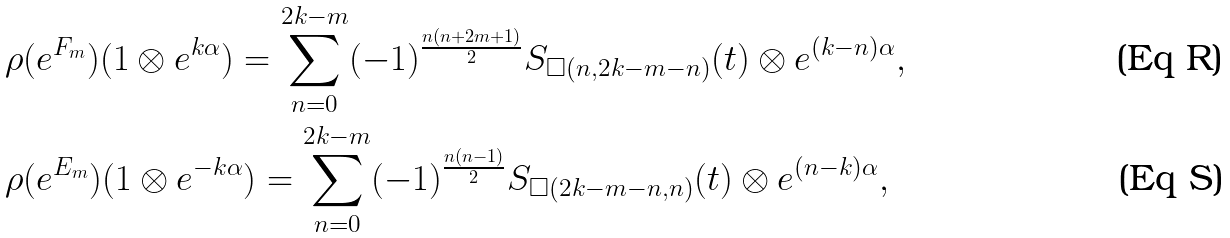<formula> <loc_0><loc_0><loc_500><loc_500>& \rho ( e ^ { F _ { m } } ) ( 1 \otimes e ^ { k \alpha } ) = \sum _ { n = 0 } ^ { 2 k - m } ( - 1 ) ^ { \frac { n ( n + 2 m + 1 ) } { 2 } } S _ { \square ( n , 2 k - m - n ) } ( t ) \otimes e ^ { ( k - n ) \alpha } , \\ & \rho ( e ^ { E _ { m } } ) ( 1 \otimes e ^ { - k \alpha } ) = \sum _ { n = 0 } ^ { 2 k - m } ( - 1 ) ^ { \frac { n ( n - 1 ) } { 2 } } S _ { \square ( 2 k - m - n , n ) } ( t ) \otimes e ^ { ( n - k ) \alpha } ,</formula> 